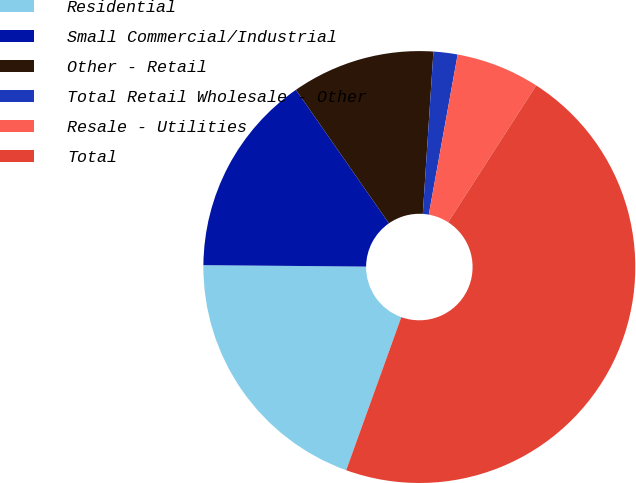<chart> <loc_0><loc_0><loc_500><loc_500><pie_chart><fcel>Residential<fcel>Small Commercial/Industrial<fcel>Other - Retail<fcel>Total Retail Wholesale - Other<fcel>Resale - Utilities<fcel>Total<nl><fcel>19.64%<fcel>15.18%<fcel>10.72%<fcel>1.8%<fcel>6.26%<fcel>46.4%<nl></chart> 